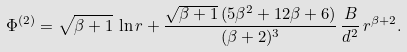<formula> <loc_0><loc_0><loc_500><loc_500>\Phi ^ { ( 2 ) } = \sqrt { \beta + 1 } \, \ln r + \frac { \sqrt { \beta + 1 } \, ( 5 \beta ^ { 2 } + 1 2 \beta + 6 ) } { ( \beta + 2 ) ^ { 3 } } \, \frac { B } { d ^ { 2 } } \, r ^ { \beta + 2 } .</formula> 